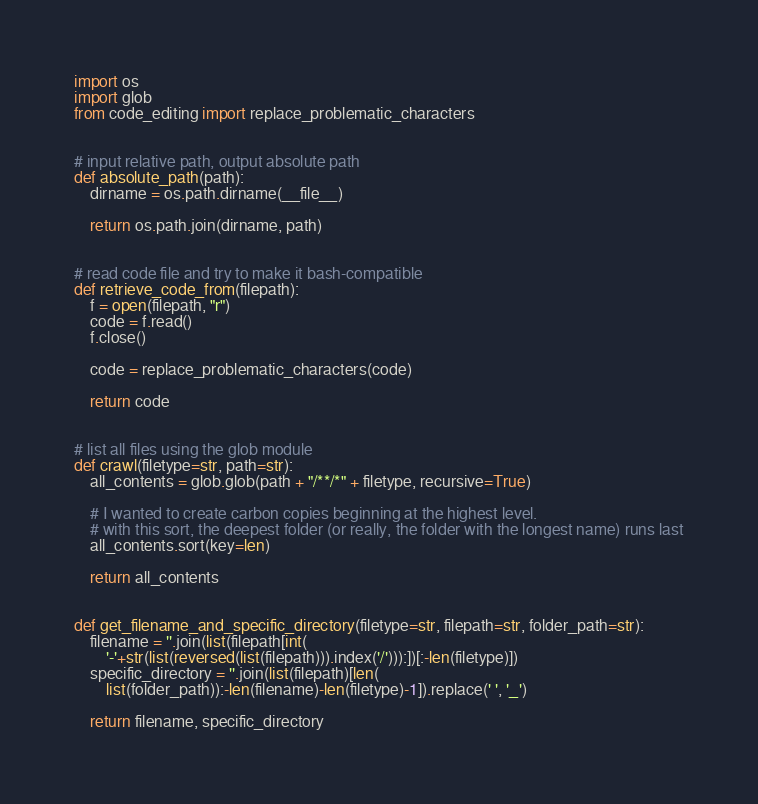Convert code to text. <code><loc_0><loc_0><loc_500><loc_500><_Python_>import os
import glob
from code_editing import replace_problematic_characters


# input relative path, output absolute path
def absolute_path(path):
    dirname = os.path.dirname(__file__)

    return os.path.join(dirname, path)


# read code file and try to make it bash-compatible
def retrieve_code_from(filepath):
    f = open(filepath, "r")
    code = f.read()
    f.close()

    code = replace_problematic_characters(code)

    return code


# list all files using the glob module
def crawl(filetype=str, path=str):
    all_contents = glob.glob(path + "/**/*" + filetype, recursive=True)

    # I wanted to create carbon copies beginning at the highest level.
    # with this sort, the deepest folder (or really, the folder with the longest name) runs last
    all_contents.sort(key=len)

    return all_contents


def get_filename_and_specific_directory(filetype=str, filepath=str, folder_path=str):
    filename = ''.join(list(filepath[int(
        '-'+str(list(reversed(list(filepath))).index('/'))):])[:-len(filetype)])
    specific_directory = ''.join(list(filepath)[len(
        list(folder_path)):-len(filename)-len(filetype)-1]).replace(' ', '_')

    return filename, specific_directory
</code> 